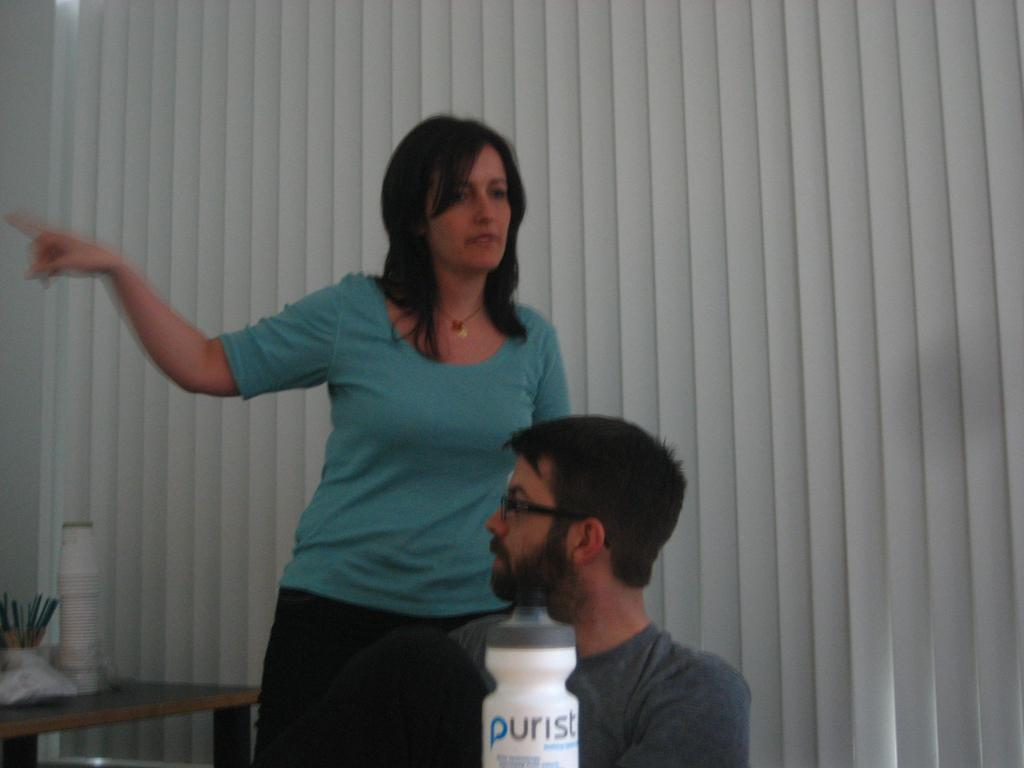Who is present in the image? There is a lady and a man in the image. What is the lady doing in the image? The lady is standing in the image. How is the lady positioned in relation to the man? The lady is standing in front of the man. What type of can is visible in the image? There is no can present in the image. What is the lady doing to herself in the image? There is no indication in the image that the lady is doing anything to herself. 